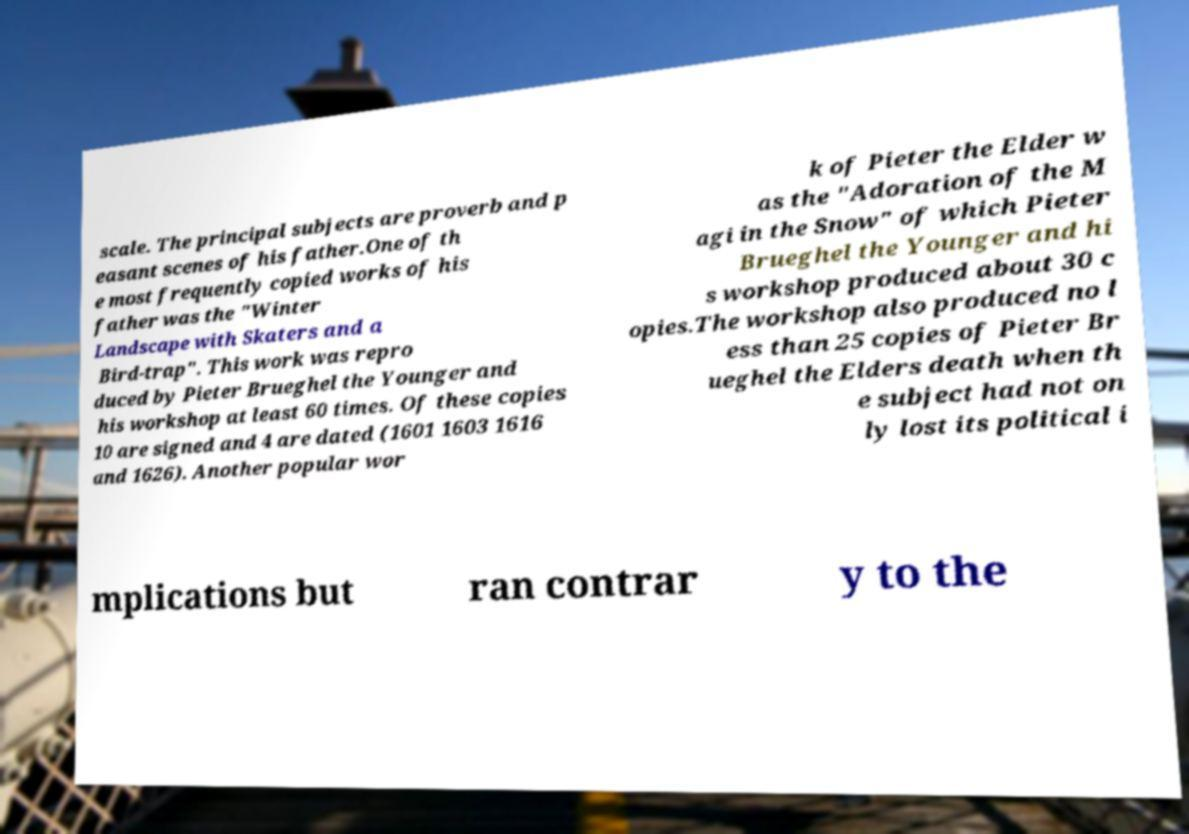Can you accurately transcribe the text from the provided image for me? scale. The principal subjects are proverb and p easant scenes of his father.One of th e most frequently copied works of his father was the "Winter Landscape with Skaters and a Bird-trap". This work was repro duced by Pieter Brueghel the Younger and his workshop at least 60 times. Of these copies 10 are signed and 4 are dated (1601 1603 1616 and 1626). Another popular wor k of Pieter the Elder w as the "Adoration of the M agi in the Snow" of which Pieter Brueghel the Younger and hi s workshop produced about 30 c opies.The workshop also produced no l ess than 25 copies of Pieter Br ueghel the Elders death when th e subject had not on ly lost its political i mplications but ran contrar y to the 